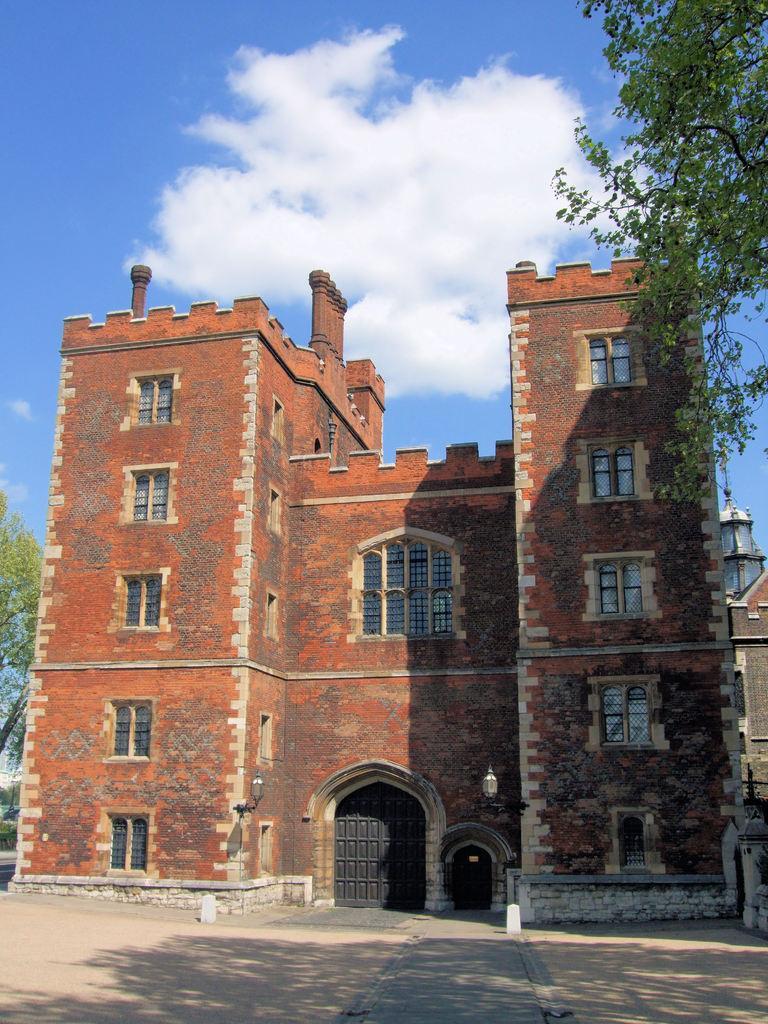Could you give a brief overview of what you see in this image? In the center of the image, we can see a building and in the background, there are trees and lights. At the top, there are clouds in the sky and at the bottom, there is a road. 